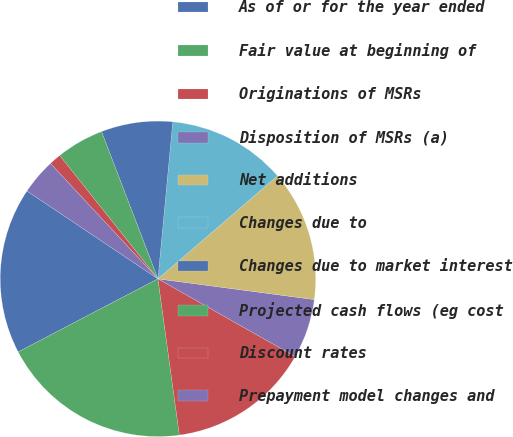Convert chart to OTSL. <chart><loc_0><loc_0><loc_500><loc_500><pie_chart><fcel>As of or for the year ended<fcel>Fair value at beginning of<fcel>Originations of MSRs<fcel>Disposition of MSRs (a)<fcel>Net additions<fcel>Changes due to<fcel>Changes due to market interest<fcel>Projected cash flows (eg cost<fcel>Discount rates<fcel>Prepayment model changes and<nl><fcel>17.07%<fcel>19.5%<fcel>14.63%<fcel>6.1%<fcel>13.41%<fcel>12.19%<fcel>7.32%<fcel>4.88%<fcel>1.23%<fcel>3.66%<nl></chart> 